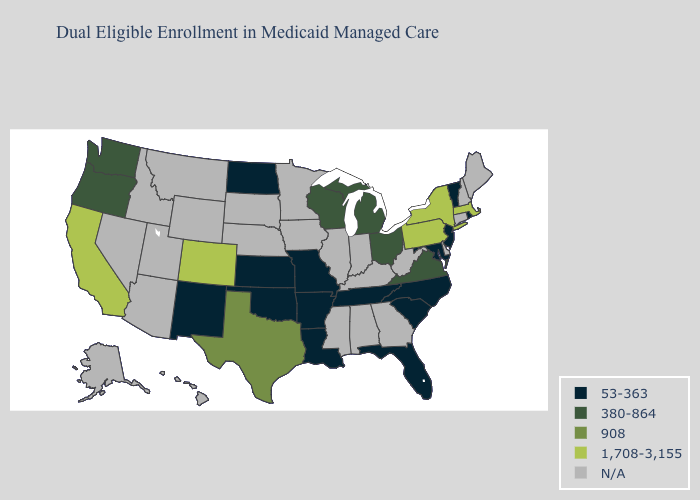Name the states that have a value in the range 908?
Answer briefly. Texas. What is the value of Nevada?
Give a very brief answer. N/A. Name the states that have a value in the range 53-363?
Keep it brief. Arkansas, Florida, Kansas, Louisiana, Maryland, Missouri, New Jersey, New Mexico, North Carolina, North Dakota, Oklahoma, Rhode Island, South Carolina, Tennessee, Vermont. Does Rhode Island have the highest value in the Northeast?
Be succinct. No. What is the value of Michigan?
Write a very short answer. 380-864. Which states have the highest value in the USA?
Concise answer only. California, Colorado, Massachusetts, New York, Pennsylvania. Name the states that have a value in the range 380-864?
Quick response, please. Michigan, Ohio, Oregon, Virginia, Washington, Wisconsin. Which states hav the highest value in the MidWest?
Answer briefly. Michigan, Ohio, Wisconsin. Among the states that border New York , does New Jersey have the lowest value?
Answer briefly. Yes. What is the highest value in the West ?
Concise answer only. 1,708-3,155. Among the states that border Pennsylvania , which have the lowest value?
Answer briefly. Maryland, New Jersey. Name the states that have a value in the range 1,708-3,155?
Keep it brief. California, Colorado, Massachusetts, New York, Pennsylvania. 